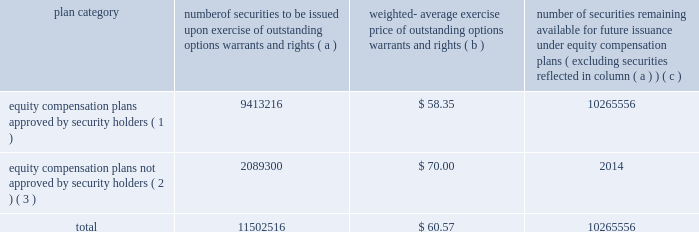Equity compensation plan information the plan documents for the plans described in the footnotes below are included as exhibits to this form 10-k , and are incorporated herein by reference in their entirety .
The table provides information as of dec .
31 , 2006 regarding the number of shares of ppg common stock that may be issued under ppg 2019s equity compensation plans .
Plan category securities exercise of outstanding options , warrants and rights weighted- average exercise price of outstanding warrants and rights number of securities remaining available for future issuance under equity compensation ( excluding securities reflected in column ( a ) ) equity compensation plans approved by security holders ( 1 ) 9413216 $ 58.35 10265556 equity compensation plans not approved by security holders ( 2 ) , ( 3 ) 2089300 $ 70.00 2014 .
( 1 ) equity compensation plans approved by security holders include the ppg industries , inc .
Stock plan , the ppg omnibus plan , the ppg industries , inc .
Executive officers 2019 long term incentive plan , and the ppg industries inc .
Long term incentive plan .
( 2 ) equity compensation plans not approved by security holders include the ppg industries , inc .
Challenge 2000 stock plan .
This plan is a broad- based stock option plan under which the company granted to substantially all active employees of the company and its majority owned subsidiaries on july 1 , 1998 , the option to purchase 100 shares of the company 2019s common stock at its then fair market value of $ 70.00 per share .
Options became exercisable on july 1 , 2003 , and expire on june 30 , 2008 .
There were 2089300 shares issuable upon exercise of options outstanding under this plan as of dec .
31 , 2006 .
( 3 ) excluded from the information presented here are common stock equivalents held under the ppg industries , inc .
Deferred compensation plan , the ppg industries , inc .
Deferred compensation plan for directors and the ppg industries , inc .
Directors 2019 common stock plan , none of which are equity compensation plans .
As supplemental information , there were 491168 common stock equivalents held under such plans as of dec .
31 , 2006 .
Item 6 .
Selected financial data the information required by item 6 regarding the selected financial data for the five years ended dec .
31 , 2006 is included in exhibit 99.2 filed with this form 10-k and is incorporated herein by reference .
This information is also reported in the eleven-year digest on page 72 of the annual report under the captions net sales , income ( loss ) before accounting changes , cumulative effect of accounting changes , net income ( loss ) , earnings ( loss ) per common share before accounting changes , cumulative effect of accounting changes on earnings ( loss ) per common share , earnings ( loss ) per common share , earnings ( loss ) per common share 2013 assuming dilution , dividends per share , total assets and long-term debt for the years 2002 through 2006 .
Item 7 .
Management 2019s discussion and analysis of financial condition and results of operations performance in 2006 compared with 2005 performance overview our sales increased 8% ( 8 % ) to $ 11.0 billion in 2006 compared to $ 10.2 billion in 2005 .
Sales increased 4% ( 4 % ) due to the impact of acquisitions , 2% ( 2 % ) due to increased volumes , and 2% ( 2 % ) due to increased selling prices .
Cost of sales as a percentage of sales increased slightly to 63.7% ( 63.7 % ) compared to 63.5% ( 63.5 % ) in 2005 .
Selling , general and administrative expense increased slightly as a percentage of sales to 17.9% ( 17.9 % ) compared to 17.4% ( 17.4 % ) in 2005 .
These costs increased primarily due to higher expenses related to store expansions in our architectural coatings operating segment and increased advertising to promote growth in our optical products operating segment .
Other charges decreased $ 81 million in 2006 .
Other charges in 2006 included pretax charges of $ 185 million for estimated environmental remediation costs at sites in new jersey and $ 42 million for legal settlements offset in part by pretax earnings of $ 44 million for insurance recoveries related to the marvin legal settlement and to hurricane rita .
Other charges in 2005 included pretax charges of $ 132 million related to the marvin legal settlement net of related insurance recoveries of $ 18 million , $ 61 million for the federal glass class action antitrust legal settlement , $ 34 million of direct costs related to the impact of hurricanes rita and katrina , $ 27 million for an asset impairment charge in our fine chemicals operating segment and $ 19 million for debt refinancing costs .
Other earnings increased $ 30 million in 2006 due to higher equity earnings , primarily from our asian fiber glass joint ventures , and higher royalty income .
Net income and earnings per share 2013 assuming dilution for 2006 were $ 711 million and $ 4.27 , respectively , compared to $ 596 million and $ 3.49 , respectively , for 2005 .
Net income in 2006 included aftertax charges of $ 106 million , or 64 cents a share , for estimated environmental remediation costs at sites in new jersey and louisiana in the third quarter ; $ 26 million , or 15 cents a share , for legal settlements ; $ 23 million , or 14 cents a share for business restructuring ; $ 17 million , or 10 cents a share , to reflect the net increase in the current value of the company 2019s obligation relating to asbestos claims under the ppg settlement arrangement ; and aftertax earnings of $ 24 million , or 14 cents a share for insurance recoveries .
Net income in 2005 included aftertax charges of $ 117 million , or 68 cents a share for legal settlements net of insurance ; $ 21 million , or 12 cents a share for direct costs related to the impact of hurricanes katrina and rita ; $ 17 million , or 10 cents a share , related to an asset impairment charge related to our fine chemicals operating segment ; $ 12 million , or 7 cents a share , for debt refinancing cost ; and $ 13 million , or 8 cents a share , to reflect the net increase in the current 2006 ppg annual report and form 10-k 19 4282_txt to be issued options , number of .
If all of the unexercised shares under the challenge 2000 stock plan were exercised , what would the increase in shareholders equity be? 
Computations: (70.00 * 2089300)
Answer: 146251000.0. Equity compensation plan information the plan documents for the plans described in the footnotes below are included as exhibits to this form 10-k , and are incorporated herein by reference in their entirety .
The table provides information as of dec .
31 , 2006 regarding the number of shares of ppg common stock that may be issued under ppg 2019s equity compensation plans .
Plan category securities exercise of outstanding options , warrants and rights weighted- average exercise price of outstanding warrants and rights number of securities remaining available for future issuance under equity compensation ( excluding securities reflected in column ( a ) ) equity compensation plans approved by security holders ( 1 ) 9413216 $ 58.35 10265556 equity compensation plans not approved by security holders ( 2 ) , ( 3 ) 2089300 $ 70.00 2014 .
( 1 ) equity compensation plans approved by security holders include the ppg industries , inc .
Stock plan , the ppg omnibus plan , the ppg industries , inc .
Executive officers 2019 long term incentive plan , and the ppg industries inc .
Long term incentive plan .
( 2 ) equity compensation plans not approved by security holders include the ppg industries , inc .
Challenge 2000 stock plan .
This plan is a broad- based stock option plan under which the company granted to substantially all active employees of the company and its majority owned subsidiaries on july 1 , 1998 , the option to purchase 100 shares of the company 2019s common stock at its then fair market value of $ 70.00 per share .
Options became exercisable on july 1 , 2003 , and expire on june 30 , 2008 .
There were 2089300 shares issuable upon exercise of options outstanding under this plan as of dec .
31 , 2006 .
( 3 ) excluded from the information presented here are common stock equivalents held under the ppg industries , inc .
Deferred compensation plan , the ppg industries , inc .
Deferred compensation plan for directors and the ppg industries , inc .
Directors 2019 common stock plan , none of which are equity compensation plans .
As supplemental information , there were 491168 common stock equivalents held under such plans as of dec .
31 , 2006 .
Item 6 .
Selected financial data the information required by item 6 regarding the selected financial data for the five years ended dec .
31 , 2006 is included in exhibit 99.2 filed with this form 10-k and is incorporated herein by reference .
This information is also reported in the eleven-year digest on page 72 of the annual report under the captions net sales , income ( loss ) before accounting changes , cumulative effect of accounting changes , net income ( loss ) , earnings ( loss ) per common share before accounting changes , cumulative effect of accounting changes on earnings ( loss ) per common share , earnings ( loss ) per common share , earnings ( loss ) per common share 2013 assuming dilution , dividends per share , total assets and long-term debt for the years 2002 through 2006 .
Item 7 .
Management 2019s discussion and analysis of financial condition and results of operations performance in 2006 compared with 2005 performance overview our sales increased 8% ( 8 % ) to $ 11.0 billion in 2006 compared to $ 10.2 billion in 2005 .
Sales increased 4% ( 4 % ) due to the impact of acquisitions , 2% ( 2 % ) due to increased volumes , and 2% ( 2 % ) due to increased selling prices .
Cost of sales as a percentage of sales increased slightly to 63.7% ( 63.7 % ) compared to 63.5% ( 63.5 % ) in 2005 .
Selling , general and administrative expense increased slightly as a percentage of sales to 17.9% ( 17.9 % ) compared to 17.4% ( 17.4 % ) in 2005 .
These costs increased primarily due to higher expenses related to store expansions in our architectural coatings operating segment and increased advertising to promote growth in our optical products operating segment .
Other charges decreased $ 81 million in 2006 .
Other charges in 2006 included pretax charges of $ 185 million for estimated environmental remediation costs at sites in new jersey and $ 42 million for legal settlements offset in part by pretax earnings of $ 44 million for insurance recoveries related to the marvin legal settlement and to hurricane rita .
Other charges in 2005 included pretax charges of $ 132 million related to the marvin legal settlement net of related insurance recoveries of $ 18 million , $ 61 million for the federal glass class action antitrust legal settlement , $ 34 million of direct costs related to the impact of hurricanes rita and katrina , $ 27 million for an asset impairment charge in our fine chemicals operating segment and $ 19 million for debt refinancing costs .
Other earnings increased $ 30 million in 2006 due to higher equity earnings , primarily from our asian fiber glass joint ventures , and higher royalty income .
Net income and earnings per share 2013 assuming dilution for 2006 were $ 711 million and $ 4.27 , respectively , compared to $ 596 million and $ 3.49 , respectively , for 2005 .
Net income in 2006 included aftertax charges of $ 106 million , or 64 cents a share , for estimated environmental remediation costs at sites in new jersey and louisiana in the third quarter ; $ 26 million , or 15 cents a share , for legal settlements ; $ 23 million , or 14 cents a share for business restructuring ; $ 17 million , or 10 cents a share , to reflect the net increase in the current value of the company 2019s obligation relating to asbestos claims under the ppg settlement arrangement ; and aftertax earnings of $ 24 million , or 14 cents a share for insurance recoveries .
Net income in 2005 included aftertax charges of $ 117 million , or 68 cents a share for legal settlements net of insurance ; $ 21 million , or 12 cents a share for direct costs related to the impact of hurricanes katrina and rita ; $ 17 million , or 10 cents a share , related to an asset impairment charge related to our fine chemicals operating segment ; $ 12 million , or 7 cents a share , for debt refinancing cost ; and $ 13 million , or 8 cents a share , to reflect the net increase in the current 2006 ppg annual report and form 10-k 19 4282_txt to be issued options , number of .
What would net income have been for 2006 without the environmental remediation costs? 
Computations: ((711 + 106) * 1000000)
Answer: 817000000.0. 